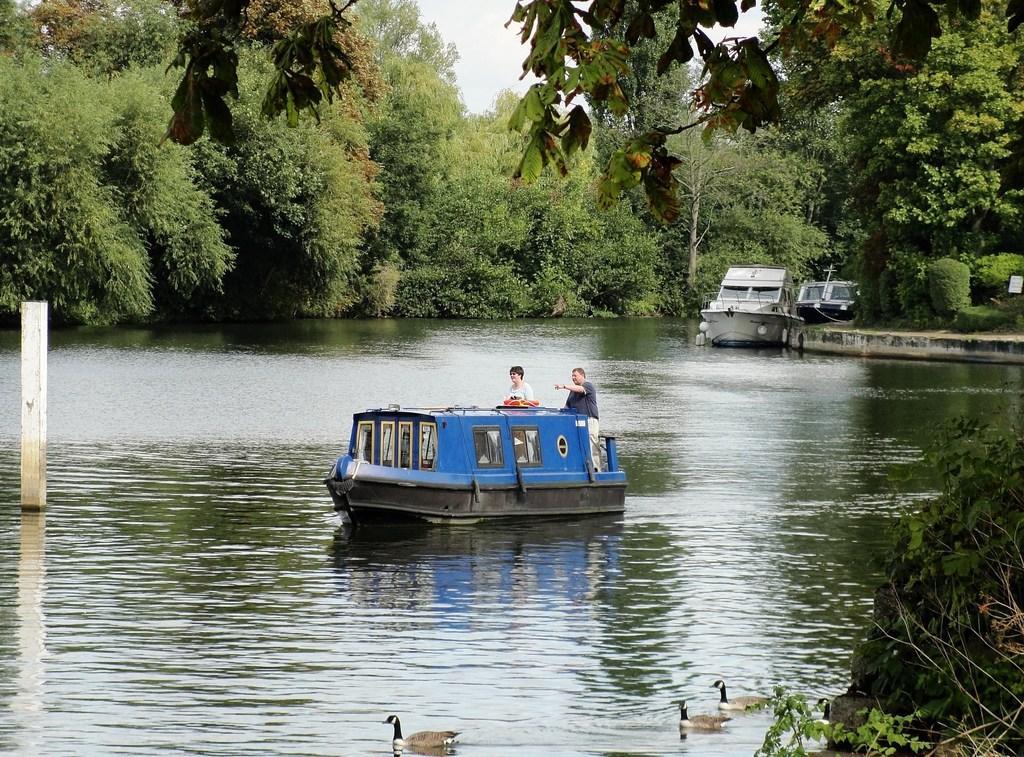Could you give a brief overview of what you see in this image? In this picture we can see water at the bottom, there are three boats in the water, we can see two persons in this boat, in the background there are some trees, we can see the sky at the top of the picture, there are three ducks at the bottom. 